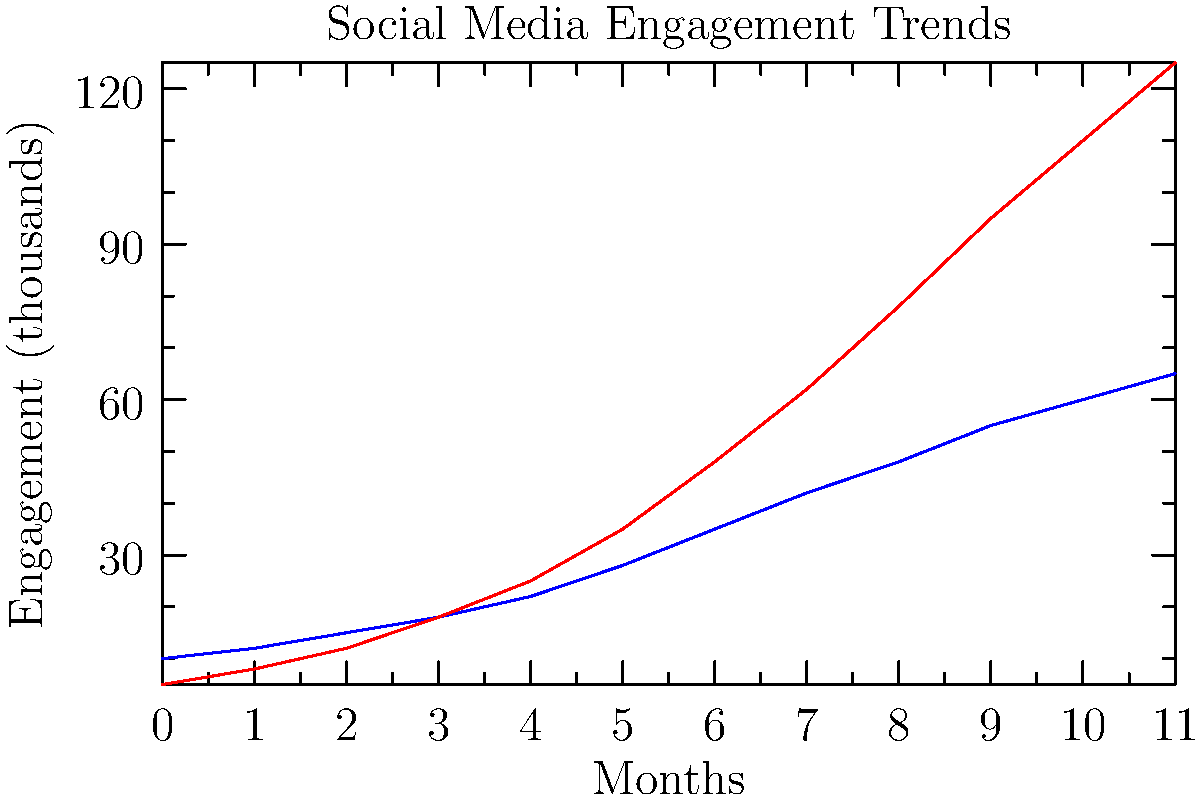Based on the line graph showing social media engagement trends for Facebook and Instagram over a 12-month period, which platform demonstrates a higher rate of growth, and what strategic implications might this have for our advertising budget allocation? To answer this question, we need to analyze the trends for both Facebook and Instagram:

1. Observe the starting points:
   - Facebook starts at around 10,000 engagements
   - Instagram starts at around 5,000 engagements

2. Compare the ending points after 12 months:
   - Facebook reaches about 65,000 engagements
   - Instagram reaches about 125,000 engagements

3. Calculate the growth rate:
   - Facebook: $(65,000 - 10,000) / 10,000 = 550\%$ growth
   - Instagram: $(125,000 - 5,000) / 5,000 = 2400\%$ growth

4. Analyze the slope of each line:
   - Instagram's line has a steeper slope, indicating faster growth

5. Consider strategic implications:
   - Instagram shows significantly higher growth rate
   - This suggests a potential shift in user engagement preferences
   - It may be beneficial to allocate more resources to Instagram advertising

6. However, also note:
   - Facebook still has substantial engagement numbers
   - A balanced approach might be necessary, not abandoning Facebook entirely

Given these observations, Instagram demonstrates a higher rate of growth. This suggests that we should consider increasing our advertising budget allocation for Instagram while maintaining a presence on Facebook.
Answer: Instagram; increase Instagram ad spend while maintaining Facebook presence. 